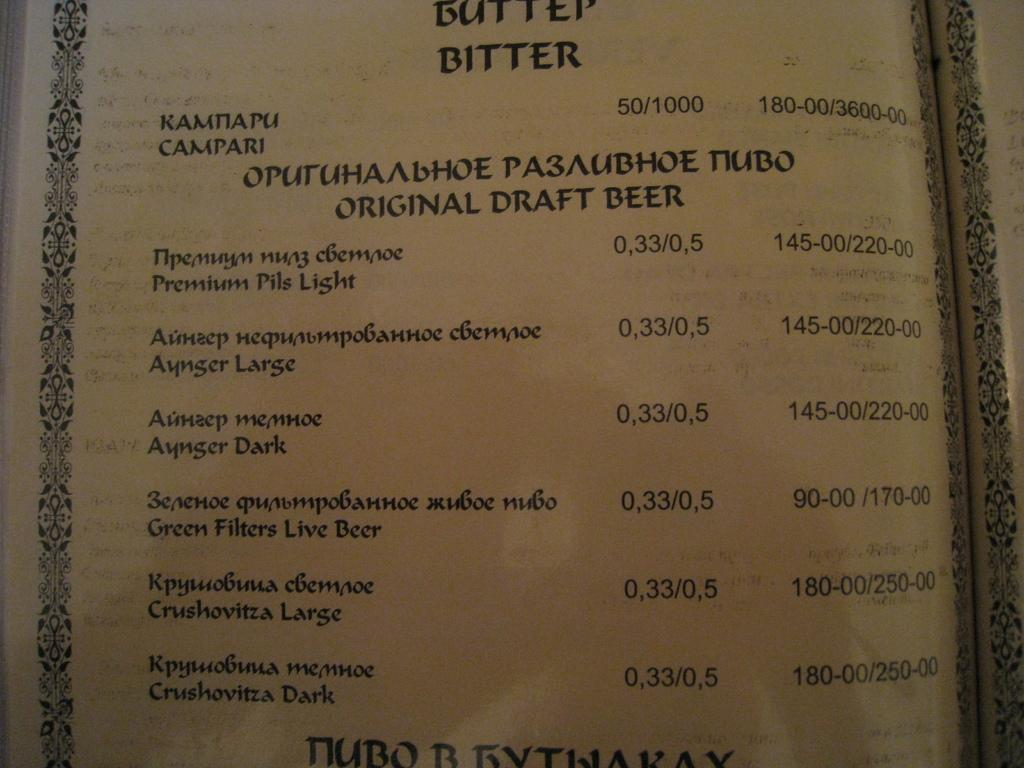Provide a one-sentence caption for the provided image. Catalog showing a list of different original draft beers. 